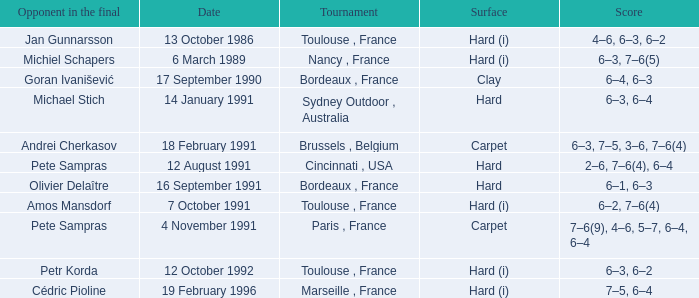What is the date of the tournament with olivier delaître as the opponent in the final? 16 September 1991. 